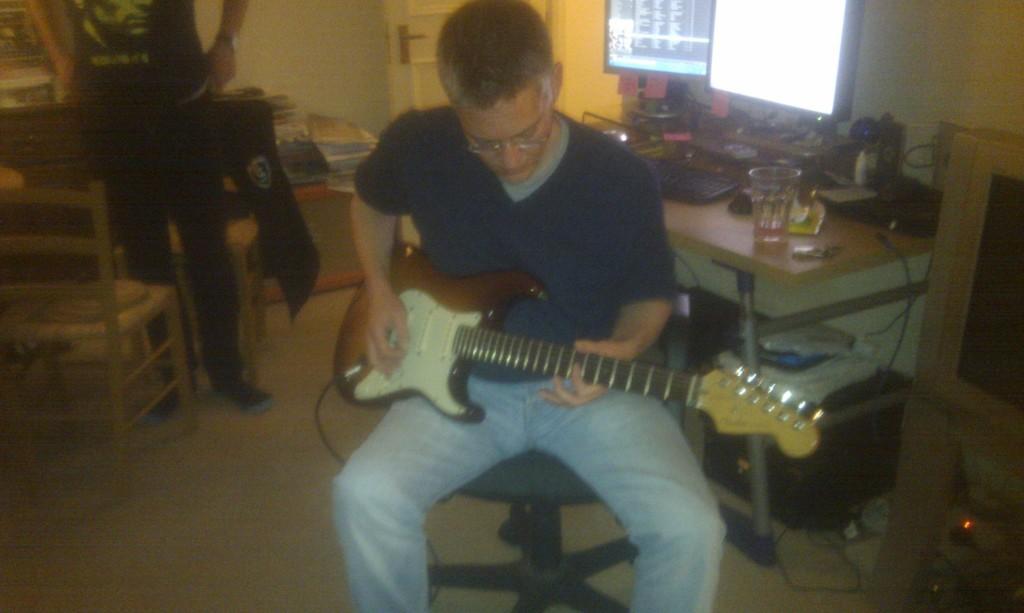In one or two sentences, can you explain what this image depicts? In the image a man wearing blue t-shirt is playing guitar. he is sitting on a chair. Beside him a man is standing there are chairs around him. On the background there are books,door. On the right there is tv beside it there is a table on it there is glass and some other things on it. There is monitors. 